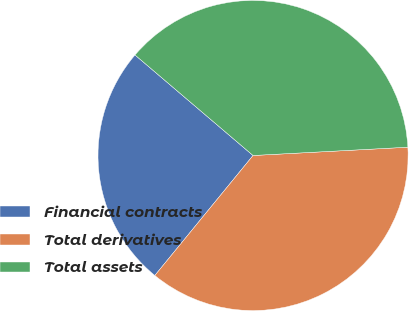Convert chart. <chart><loc_0><loc_0><loc_500><loc_500><pie_chart><fcel>Financial contracts<fcel>Total derivatives<fcel>Total assets<nl><fcel>25.31%<fcel>36.77%<fcel>37.92%<nl></chart> 